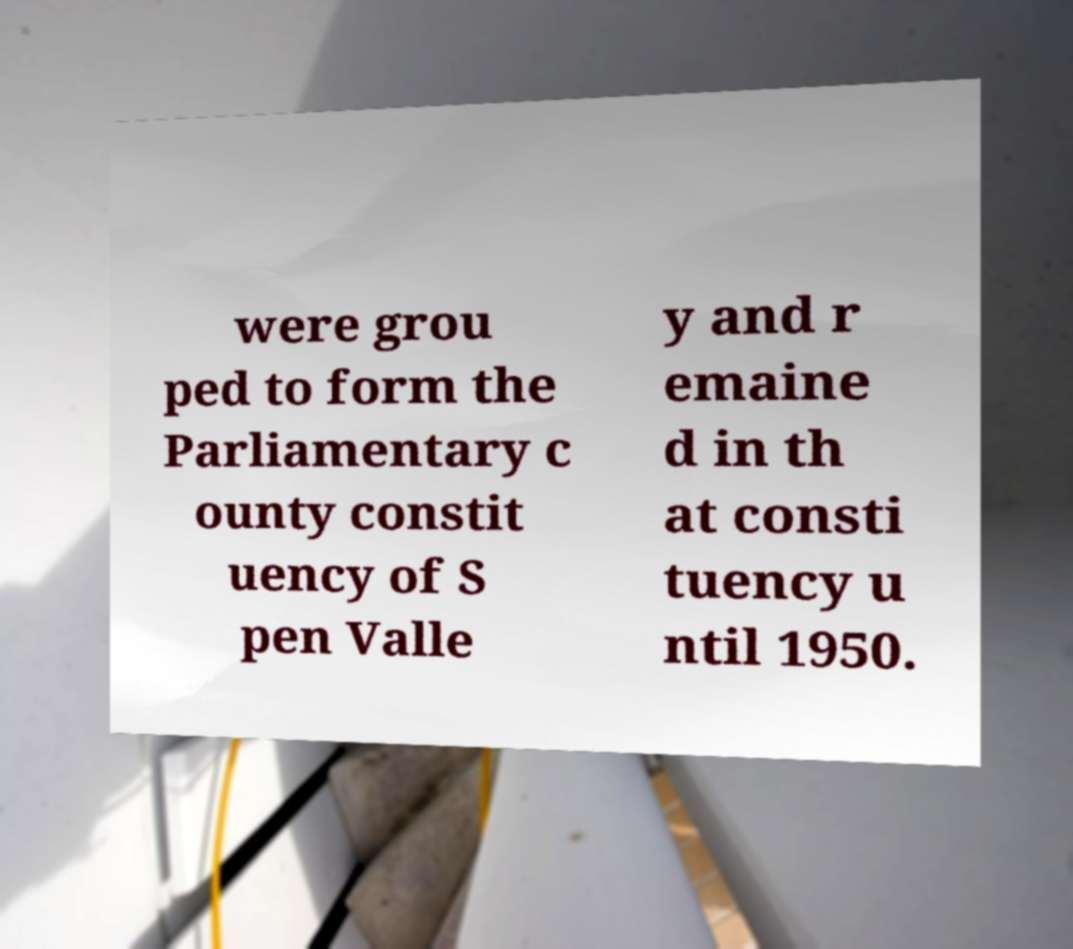Could you extract and type out the text from this image? were grou ped to form the Parliamentary c ounty constit uency of S pen Valle y and r emaine d in th at consti tuency u ntil 1950. 